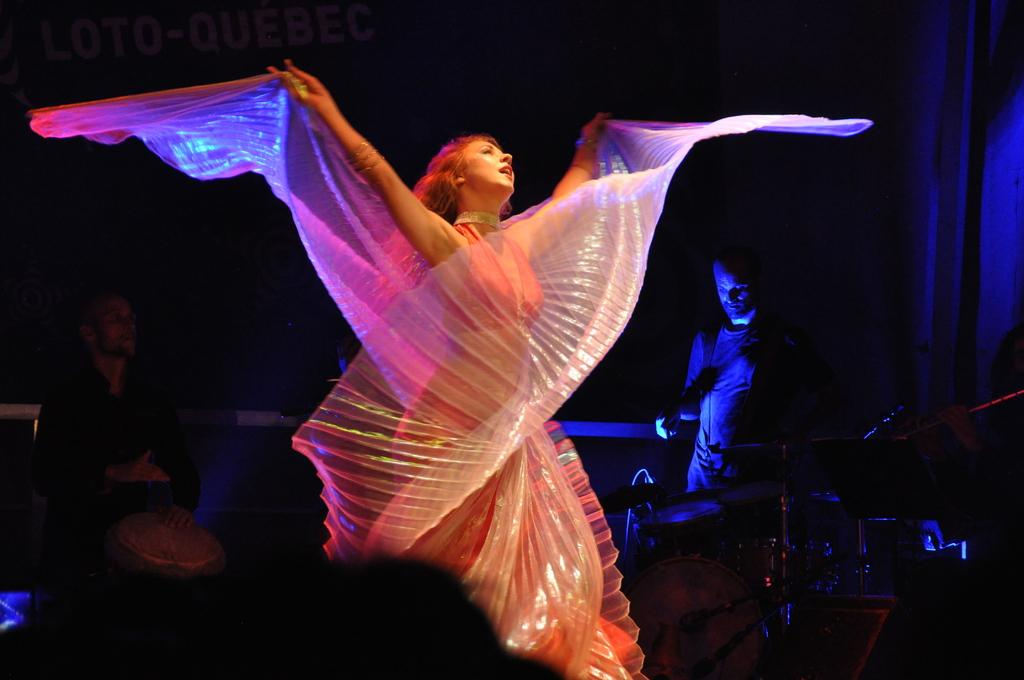What is the main subject of the image? There is a woman standing in the image. How many people are in the image? There are two persons in the image. What musical instruments are present in the image? There are drums and cymbals with cymbal stands in the image. What other objects can be seen in the image? There are other objects in the image, but their specific details are not mentioned in the provided facts. What is the color of the background in the image? The background of the image is dark. What type of organization is depicted in the image? There is no organization depicted in the image; it features a woman, two persons, drums, cymbals with cymbal stands, and other unspecified objects. What type of plough is being used by the woman in the image? There is no plough present in the image; it features a woman, two persons, drums, cymbals with cymbal stands, and other unspecified objects. 